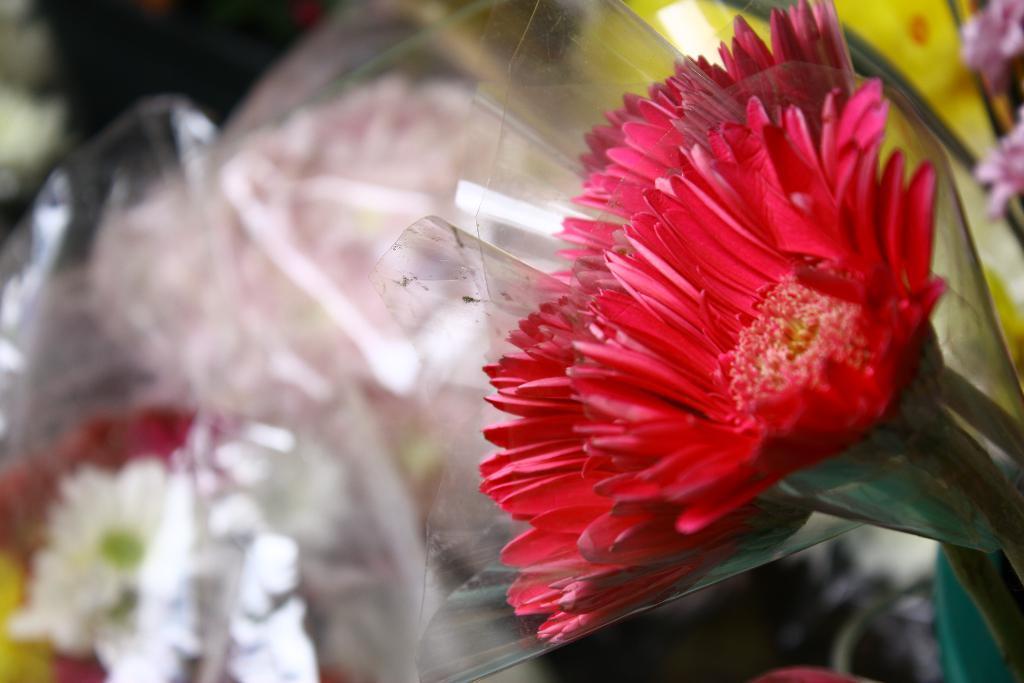Describe this image in one or two sentences. In this image I can see few red colour flowers in the front. I can also see few more flowers and plastic covers in the background. I can also see this image is little bit blurry in the background. 